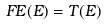<formula> <loc_0><loc_0><loc_500><loc_500>F E ( E ) = T ( E )</formula> 